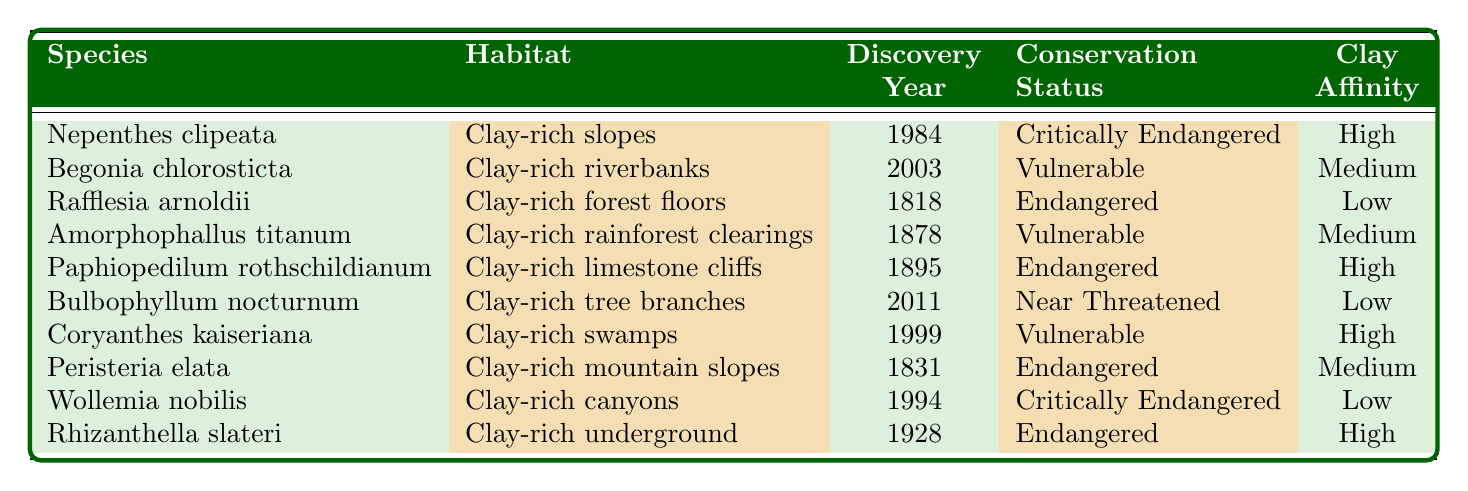What is the habitat of Nepenthes clipeata? The table states that Nepenthes clipeata is found in "Clay-rich slopes."
Answer: Clay-rich slopes How many plant species were discovered in the 2000s? The table shows two species, Begonia chlorosticta (2003) and Bulbophyllum nocturnum (2011), were discovered in the 2000s.
Answer: 2 Is Paphiopedilum rothschildianum critically endangered? The table indicates that Paphiopedilum rothschildianum is classified as "Endangered," not critically endangered.
Answer: No Which species has the highest clay affinity? The species with high clay affinity according to the table are: Nepenthes clipeata, Paphiopedilum rothschildianum, Coryanthes kaiseriana, and Rhizanthella slateri; there are four species with high clay affinity.
Answer: 4 Which species was discovered most recently? The most recently discovered species is Bulbophyllum nocturnum in 2011, as noted in the discovery year column.
Answer: Bulbophyllum nocturnum What conservation status is shared by Begonia chlorosticta and Amorphophallus titanum? Both species share the conservation status of "Vulnerable," as indicated in the table.
Answer: Vulnerable Which habitat has the most species listed? The habitats "Clay-rich slopes", "Clay-rich swamps", and "Clay-rich riverbanks" all have one species each, but the "Clay-rich forest floors" and "Clay-rich rainforest clearings" have also one each; no habitat has more than one species listed.
Answer: None What is the average discovery year of all species listed? To calculate the average, we sum the discovery years (1984 + 2003 + 1818 + 1878 + 1895 + 2011 + 1999 + 1831 + 1994 + 1928 =  1874.7), divided by 10 species. Therefore, the average discovery year is roughly 1875.
Answer: 1875 How many Critically Endangered species are there? Referring to the table, there are two species classified as "Critically Endangered": Nepenthes clipeata and Wollemia nobilis.
Answer: 2 Is there any species that has low clay affinity and is also endangered? The table shows Rafflesia arnoldii (Endangered) and Wollemia nobilis (Critically Endangered) are noted with low clay affinity; however, only Rafflesia arnoldii is classified as endangered with low clay affinity.
Answer: Yes 